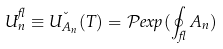Convert formula to latex. <formula><loc_0><loc_0><loc_500><loc_500>U _ { n } ^ { \gamma } \equiv U ^ { \lambda } _ { A _ { n } } ( T ) = \mathcal { P } e x p ( \oint _ { \gamma } A _ { n } )</formula> 